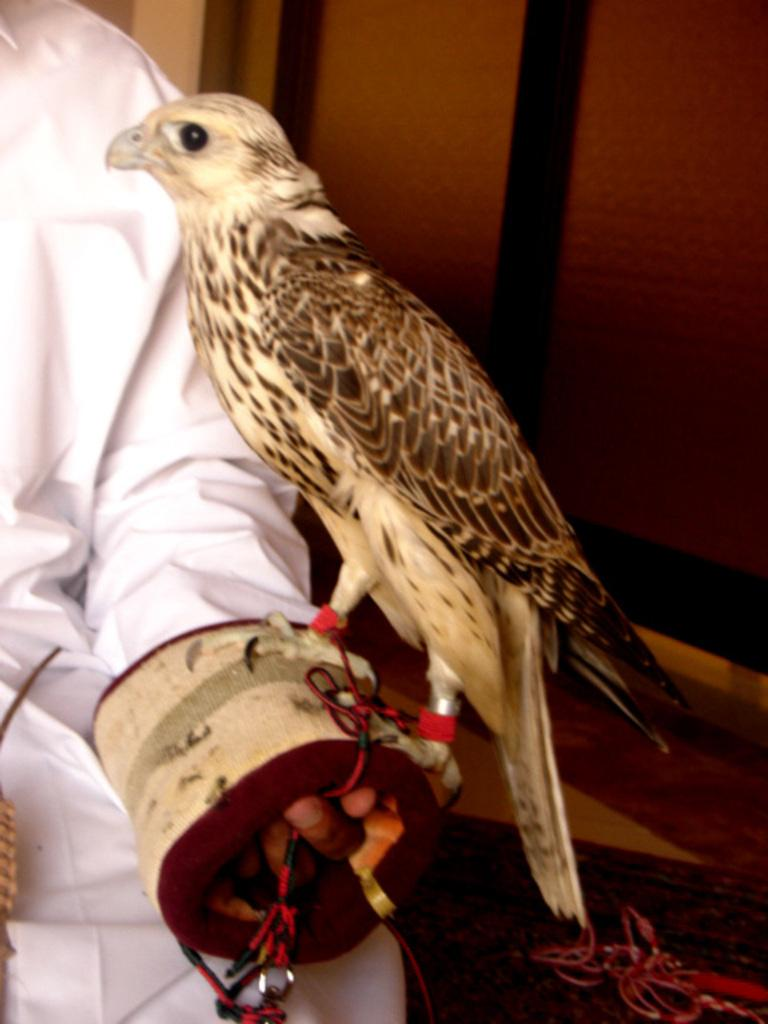What animal can be seen in the picture? There is an eagle in the picture. Where is the eagle located in the image? The eagle is sitting on the hand of a man. What can be seen in the background of the picture? There is a wall in the background of the picture. How many cherries are hanging from the trees in the image? There are no cherries or trees present in the image; it features an eagle sitting on a man's hand with a wall in the background. 